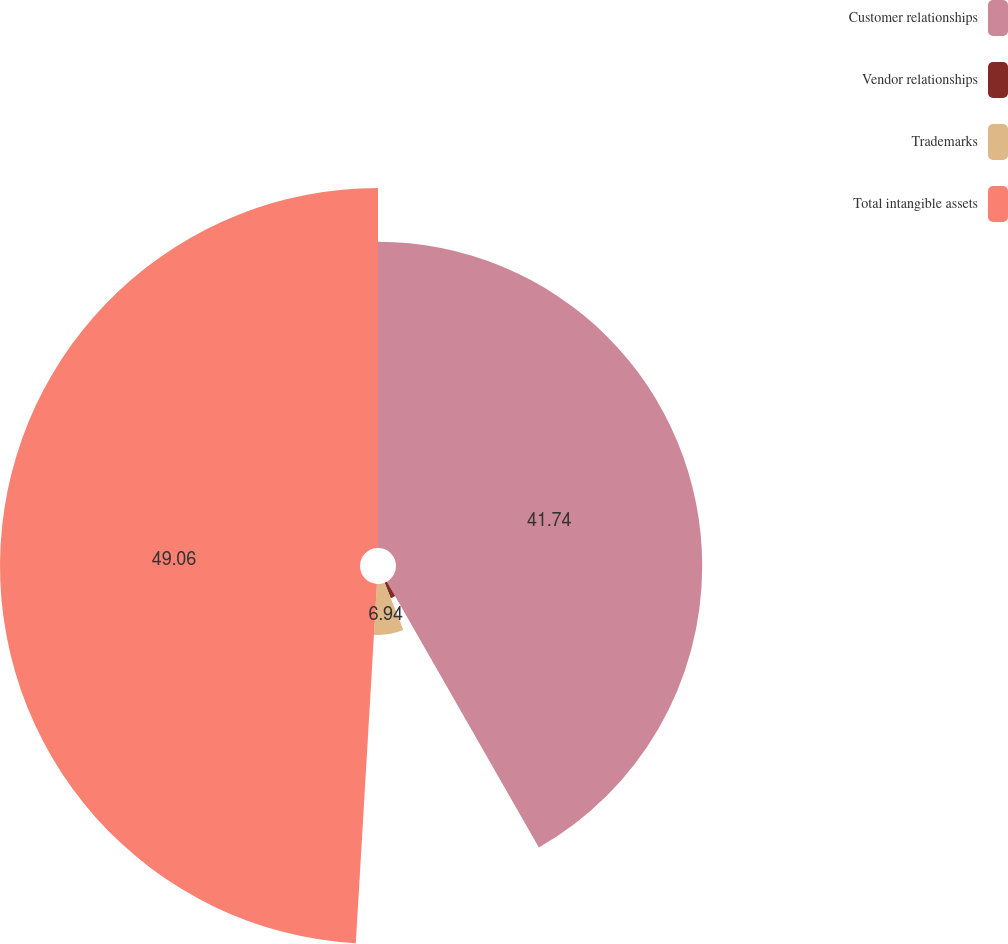Convert chart to OTSL. <chart><loc_0><loc_0><loc_500><loc_500><pie_chart><fcel>Customer relationships<fcel>Vendor relationships<fcel>Trademarks<fcel>Total intangible assets<nl><fcel>41.74%<fcel>2.26%<fcel>6.94%<fcel>49.07%<nl></chart> 